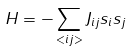Convert formula to latex. <formula><loc_0><loc_0><loc_500><loc_500>H = - \sum _ { < i j > } J _ { i j } s _ { i } s _ { j }</formula> 